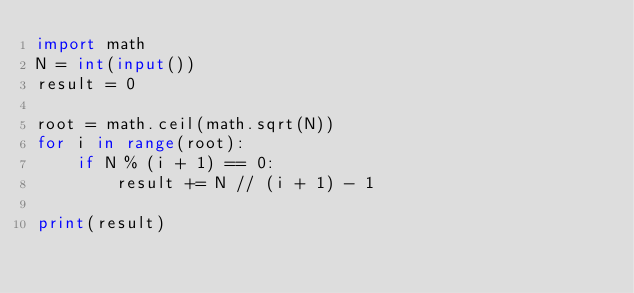<code> <loc_0><loc_0><loc_500><loc_500><_Python_>import math
N = int(input())
result = 0

root = math.ceil(math.sqrt(N))
for i in range(root):
    if N % (i + 1) == 0:
        result += N // (i + 1) - 1

print(result)</code> 